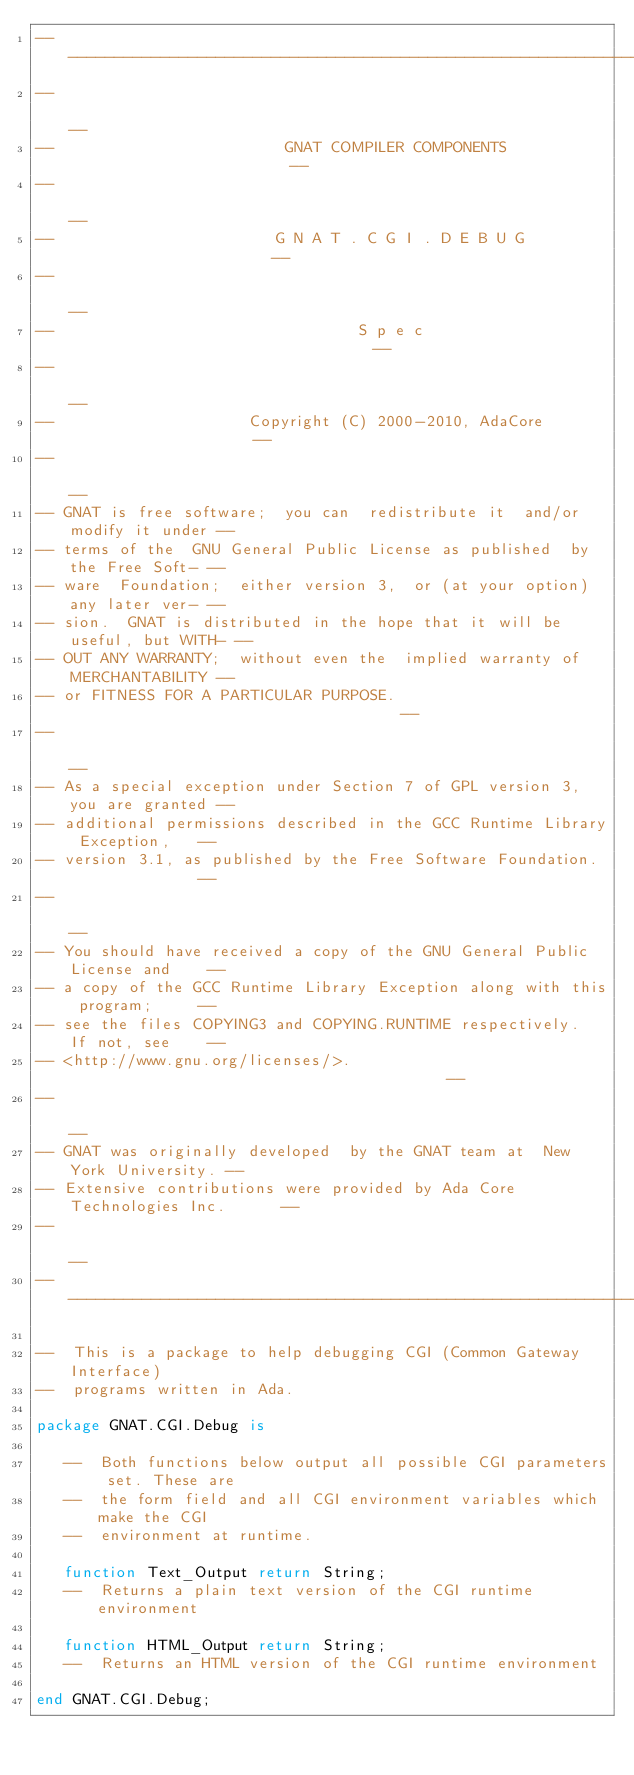<code> <loc_0><loc_0><loc_500><loc_500><_Ada_>------------------------------------------------------------------------------
--                                                                          --
--                         GNAT COMPILER COMPONENTS                         --
--                                                                          --
--                        G N A T . C G I . D E B U G                       --
--                                                                          --
--                                 S p e c                                  --
--                                                                          --
--                     Copyright (C) 2000-2010, AdaCore                     --
--                                                                          --
-- GNAT is free software;  you can  redistribute it  and/or modify it under --
-- terms of the  GNU General Public License as published  by the Free Soft- --
-- ware  Foundation;  either version 3,  or (at your option) any later ver- --
-- sion.  GNAT is distributed in the hope that it will be useful, but WITH- --
-- OUT ANY WARRANTY;  without even the  implied warranty of MERCHANTABILITY --
-- or FITNESS FOR A PARTICULAR PURPOSE.                                     --
--                                                                          --
-- As a special exception under Section 7 of GPL version 3, you are granted --
-- additional permissions described in the GCC Runtime Library Exception,   --
-- version 3.1, as published by the Free Software Foundation.               --
--                                                                          --
-- You should have received a copy of the GNU General Public License and    --
-- a copy of the GCC Runtime Library Exception along with this program;     --
-- see the files COPYING3 and COPYING.RUNTIME respectively.  If not, see    --
-- <http://www.gnu.org/licenses/>.                                          --
--                                                                          --
-- GNAT was originally developed  by the GNAT team at  New York University. --
-- Extensive contributions were provided by Ada Core Technologies Inc.      --
--                                                                          --
------------------------------------------------------------------------------

--  This is a package to help debugging CGI (Common Gateway Interface)
--  programs written in Ada.

package GNAT.CGI.Debug is

   --  Both functions below output all possible CGI parameters set. These are
   --  the form field and all CGI environment variables which make the CGI
   --  environment at runtime.

   function Text_Output return String;
   --  Returns a plain text version of the CGI runtime environment

   function HTML_Output return String;
   --  Returns an HTML version of the CGI runtime environment

end GNAT.CGI.Debug;
</code> 